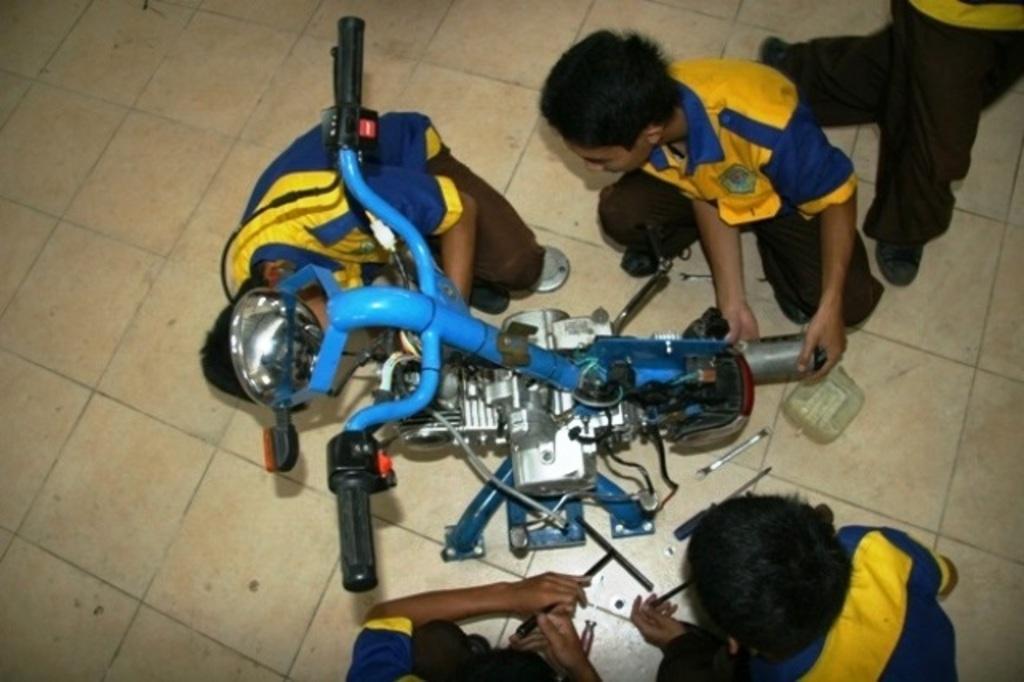Can you describe this image briefly? In this image we can see people sitting on the ground and a motor vehicle. 